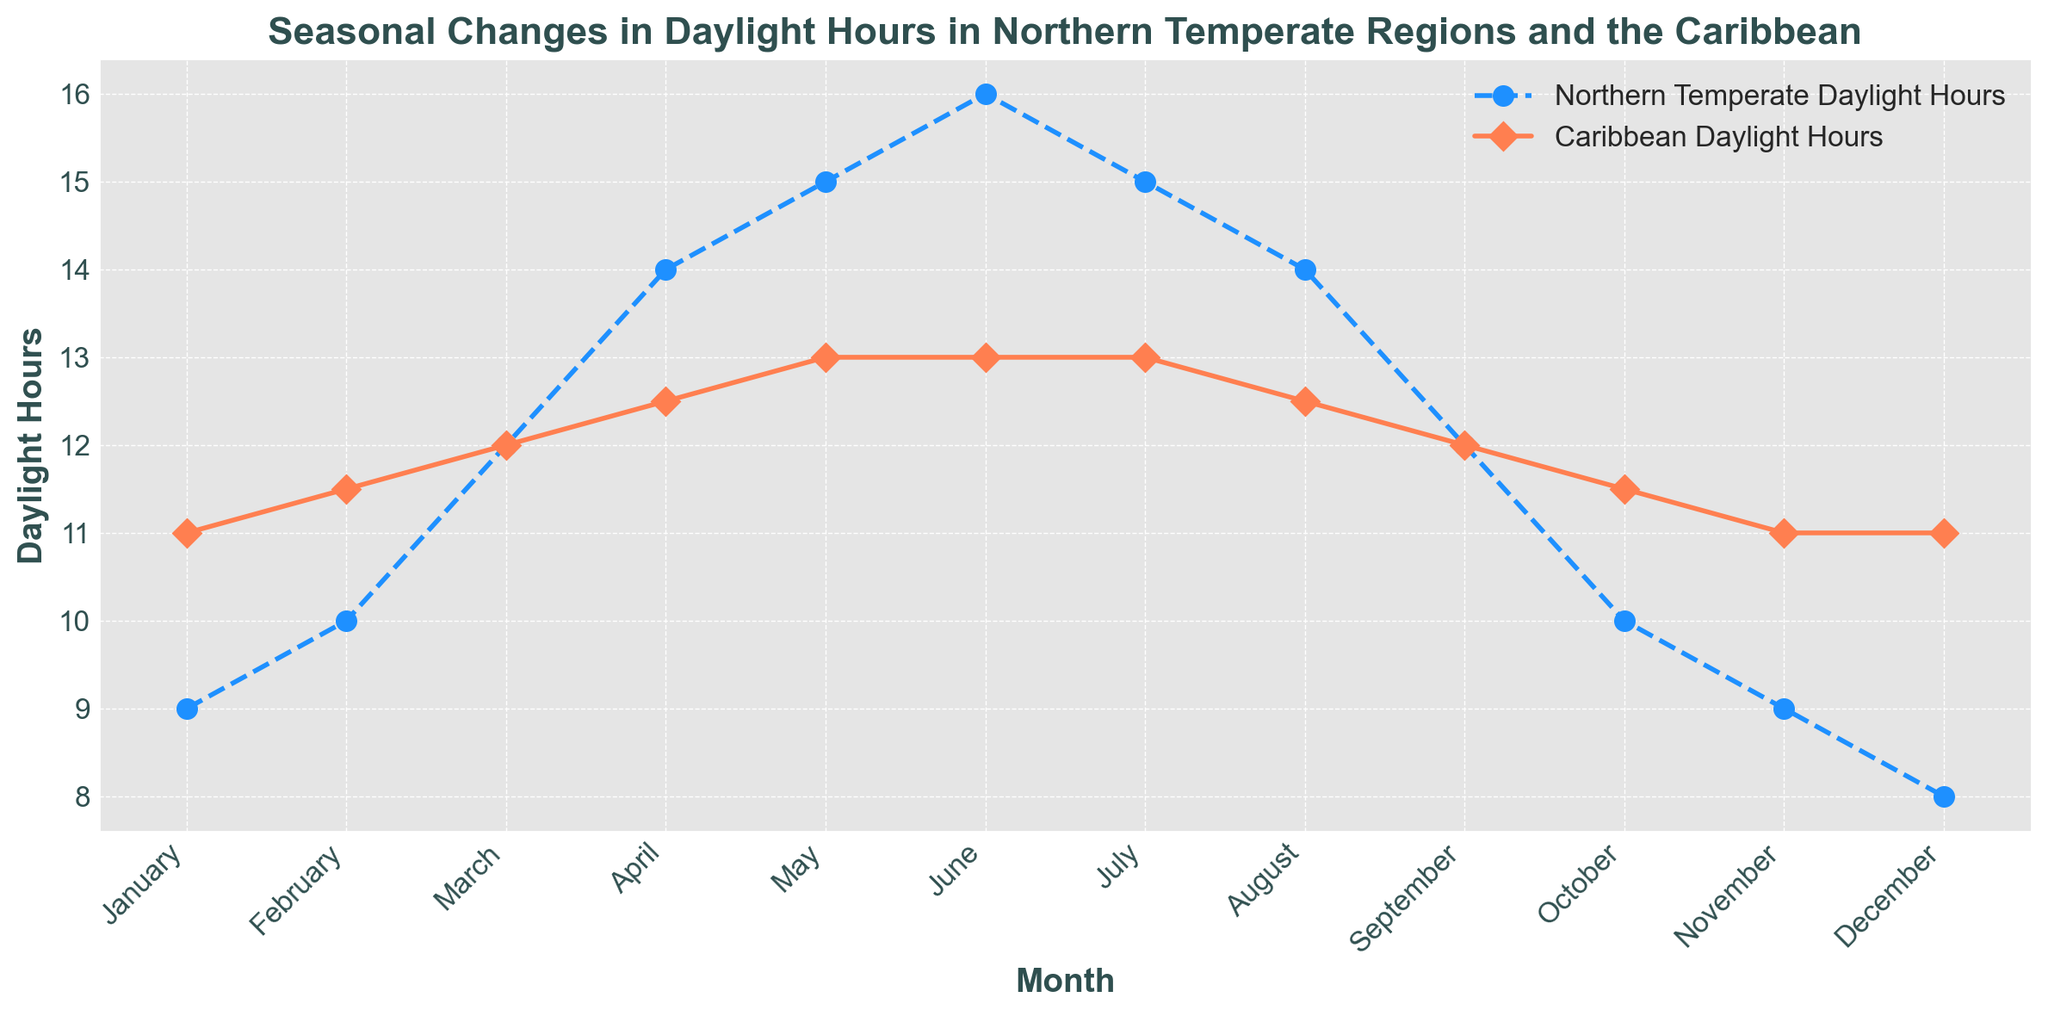What are the daylight hours in the Northern Temperate region and the Caribbean in June? For June, locate the values on the plot for both the Northern Temperate region and the Caribbean. Northern Temperate is at 16 hours and the Caribbean is at 13 hours.
Answer: 16 hours (Northern Temperate), 13 hours (Caribbean) What is the difference in daylight hours between the Northern Temperate region and the Caribbean in December? For December, locate the values on the plot. Northern Temperate is at 8 hours and the Caribbean is at 11 hours. The difference is 11 - 8 = 3 hours.
Answer: 3 hours Which region has more consistent daylight hours throughout the year? Observe the trend lines for both regions over the months. The Caribbean has a relatively flat line, indicating more consistent daylight hours, whereas the Northern Temperate region has a more variable line.
Answer: Caribbean In which month does the Northern Temperate region have the maximum daylight hours? Locate the peak of the Northern Temperate region's plot line. The maximum daylight hours occur in June, with 16 hours.
Answer: June Compare the daylight hours in January and July for the Northern Temperate region. In January, the Northern Temperate region has 9 daylight hours, and in July, it has 15 daylight hours. July has more daylight hours than January by 15 - 9 = 6 hours.
Answer: July (6 hours more) What is the average daylight hours in the Caribbean during March, April, and May? Add the daylight hours for Caribbean in March (12), April (12.5), and May (13). The sum is 12 + 12.5 + 13 = 37.5. Divide by 3 to find the average: 37.5 / 3 = 12.5.
Answer: 12.5 hours During which months does the Northern Temperate region experience the shortest daylight hours? Locate the lowest points on the plot line for the Northern Temperate region. The shortest daylight hours are in December, with 8 hours, followed by January and November with 9 hours each.
Answer: December What is the trend in daylight hours for the Caribbean from January to June? Observe the plot line for the Caribbean from January to June. Daylight hours increase from 11 hours in January to 13 hours in June.
Answer: Increasing Identify the months where both regions have the same daylight hours. Locate points where the plot lines for both regions intersect. Both regions have 12 daylight hours in March and September.
Answer: March, September How much does the daylight hours in the Northern Temperate region change between February and August? In February, the Northern Temperate region has 10 daylight hours, and in August, it has 14 hours. The change is 14 - 10 = 4 hours.
Answer: 4 hours 